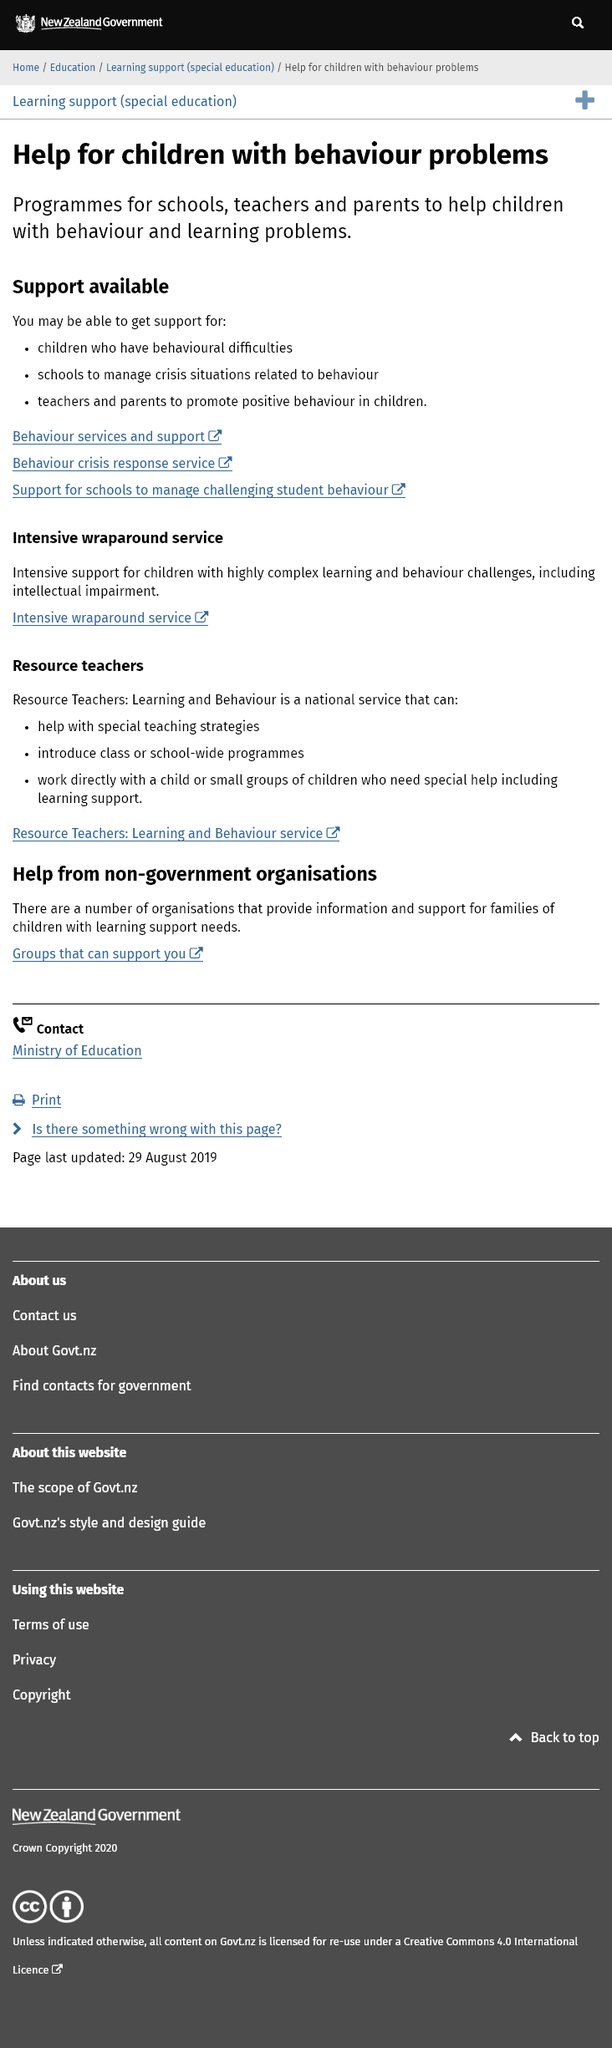Draw attention to some important aspects in this diagram. Children with behavioral problems are helped by programs, schools, teachers, and parents. The provided header "Help for children with behavioural problems" includes links to various services and support, including behaviour services and support, crisis response services, support for schools to manage challenging student behaviour, and intensive wraparound services. The Intensive wraparound service is a support program that provides intensive support for children with highly complex learning and behavioral challenges, including intellectual impairment. 